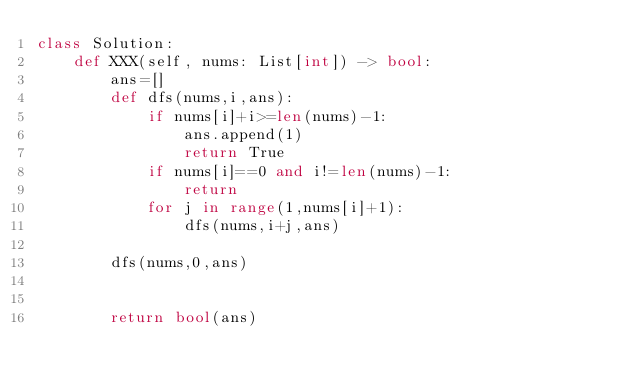<code> <loc_0><loc_0><loc_500><loc_500><_Python_>class Solution:
    def XXX(self, nums: List[int]) -> bool:
        ans=[]
        def dfs(nums,i,ans):
            if nums[i]+i>=len(nums)-1:
                ans.append(1)                 
                return True            
            if nums[i]==0 and i!=len(nums)-1:                 
                return               
            for j in range(1,nums[i]+1):                 
                dfs(nums,i+j,ans)
             
        dfs(nums,0,ans)

        
        return bool(ans)

</code> 